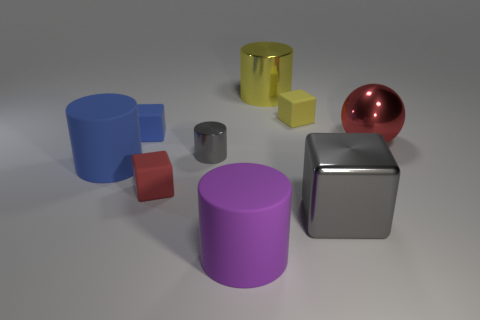Subtract all red cylinders. Subtract all blue cubes. How many cylinders are left? 4 Add 1 large green rubber cubes. How many objects exist? 10 Subtract all cubes. How many objects are left? 5 Add 8 big yellow things. How many big yellow things exist? 9 Subtract 1 blue blocks. How many objects are left? 8 Subtract all big purple rubber cylinders. Subtract all red matte things. How many objects are left? 7 Add 8 small blue things. How many small blue things are left? 9 